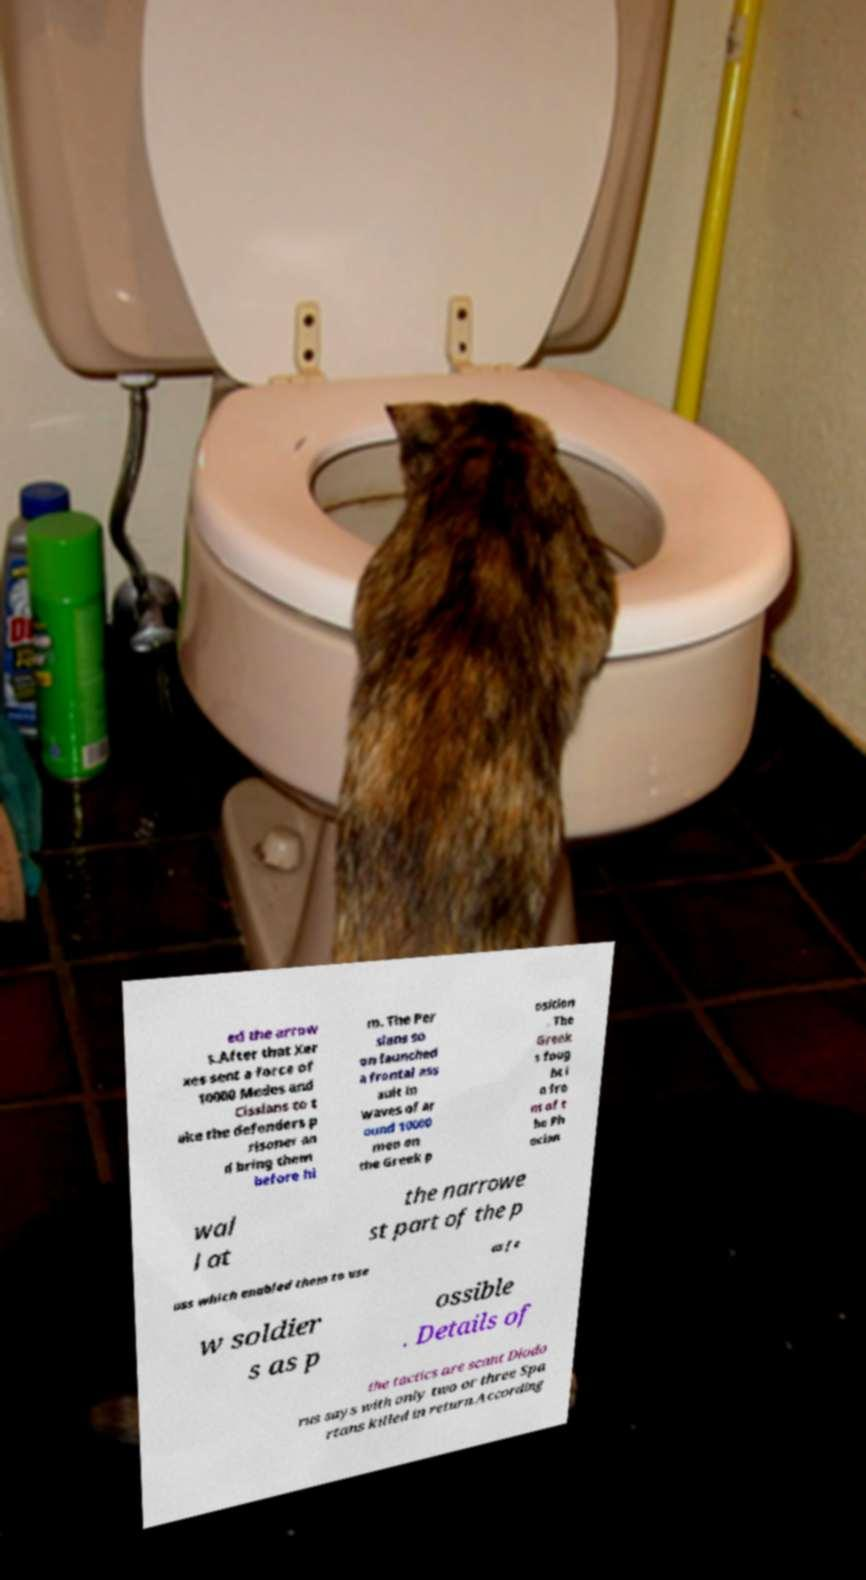Can you accurately transcribe the text from the provided image for me? ed the arrow s.After that Xer xes sent a force of 10000 Medes and Cissians to t ake the defenders p risoner an d bring them before hi m. The Per sians so on launched a frontal ass ault in waves of ar ound 10000 men on the Greek p osition . The Greek s foug ht i n fro nt of t he Ph ocian wal l at the narrowe st part of the p ass which enabled them to use as fe w soldier s as p ossible . Details of the tactics are scant Diodo rus says with only two or three Spa rtans killed in return.According 